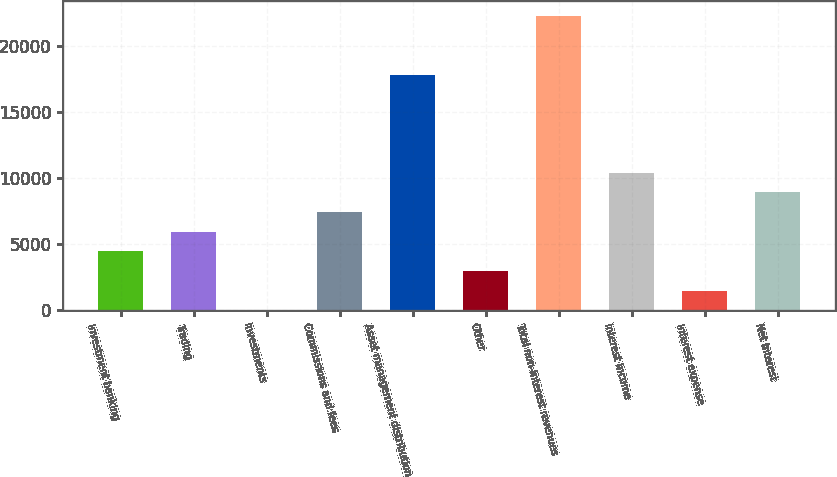<chart> <loc_0><loc_0><loc_500><loc_500><bar_chart><fcel>Investment banking<fcel>Trading<fcel>Investments<fcel>Commissions and fees<fcel>Asset management distribution<fcel>Other<fcel>Total non-interest revenues<fcel>Interest income<fcel>Interest expense<fcel>Net interest<nl><fcel>4472.7<fcel>5960.6<fcel>9<fcel>7448.5<fcel>17863.8<fcel>2984.8<fcel>22327.5<fcel>10424.3<fcel>1496.9<fcel>8936.4<nl></chart> 